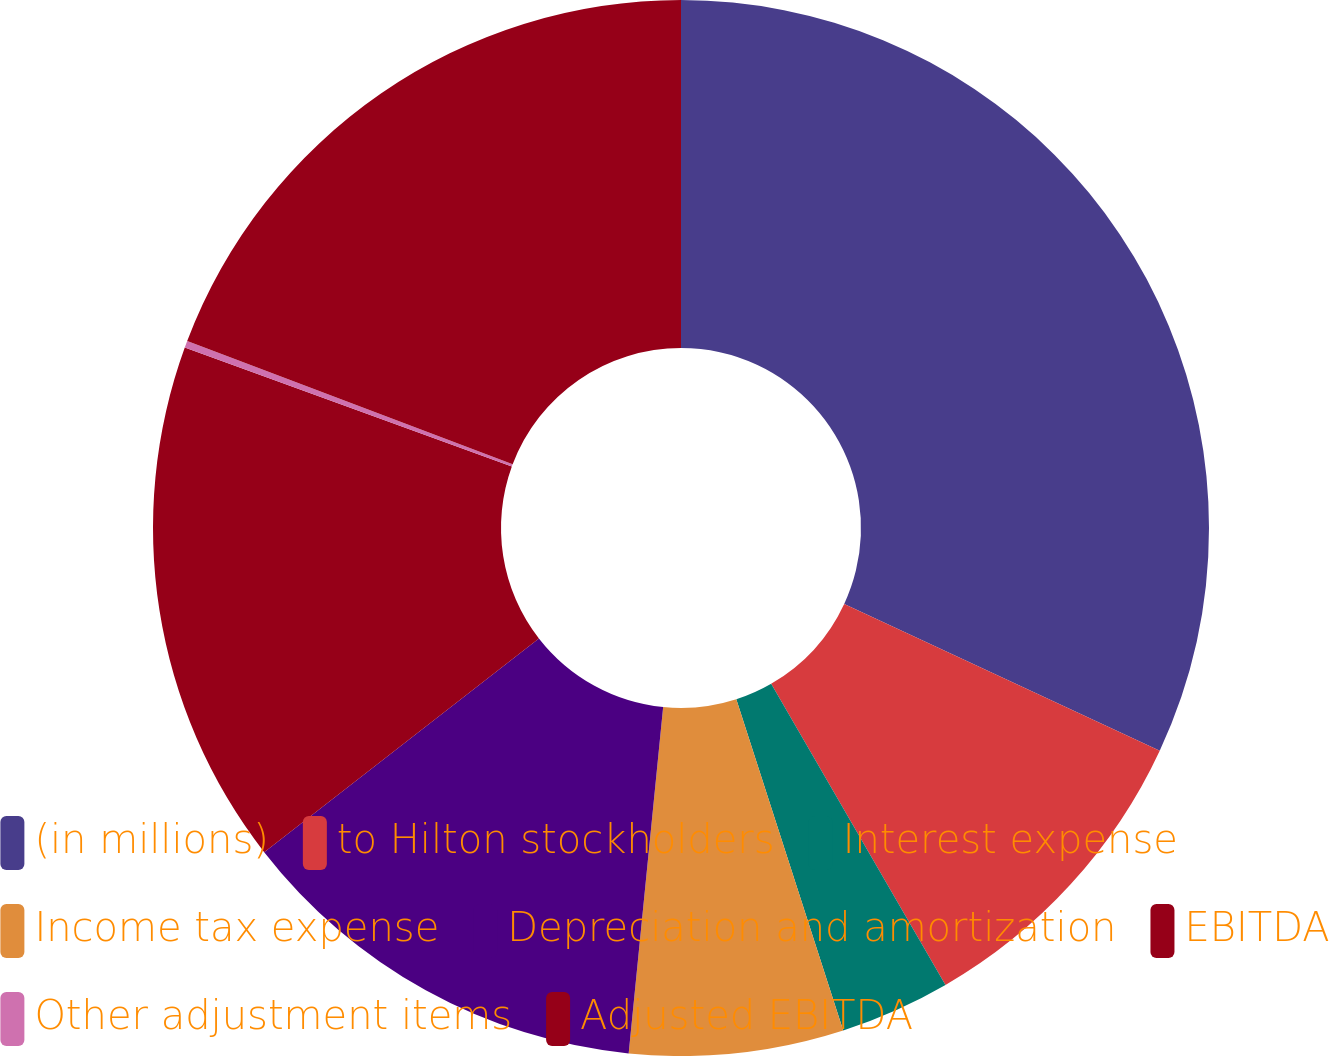<chart> <loc_0><loc_0><loc_500><loc_500><pie_chart><fcel>(in millions)<fcel>to Hilton stockholders<fcel>Interest expense<fcel>Income tax expense<fcel>Depreciation and amortization<fcel>EBITDA<fcel>Other adjustment items<fcel>Adjusted EBITDA<nl><fcel>31.93%<fcel>9.72%<fcel>3.38%<fcel>6.55%<fcel>12.9%<fcel>16.07%<fcel>0.21%<fcel>19.24%<nl></chart> 